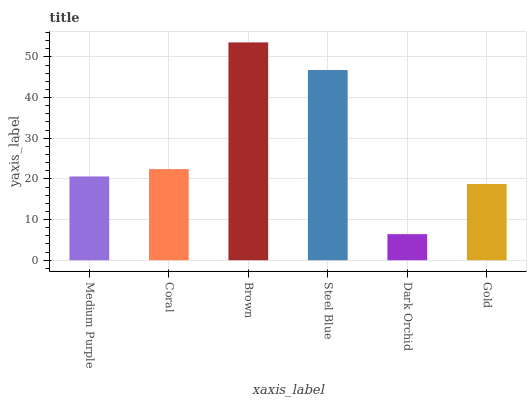Is Dark Orchid the minimum?
Answer yes or no. Yes. Is Brown the maximum?
Answer yes or no. Yes. Is Coral the minimum?
Answer yes or no. No. Is Coral the maximum?
Answer yes or no. No. Is Coral greater than Medium Purple?
Answer yes or no. Yes. Is Medium Purple less than Coral?
Answer yes or no. Yes. Is Medium Purple greater than Coral?
Answer yes or no. No. Is Coral less than Medium Purple?
Answer yes or no. No. Is Coral the high median?
Answer yes or no. Yes. Is Medium Purple the low median?
Answer yes or no. Yes. Is Medium Purple the high median?
Answer yes or no. No. Is Steel Blue the low median?
Answer yes or no. No. 